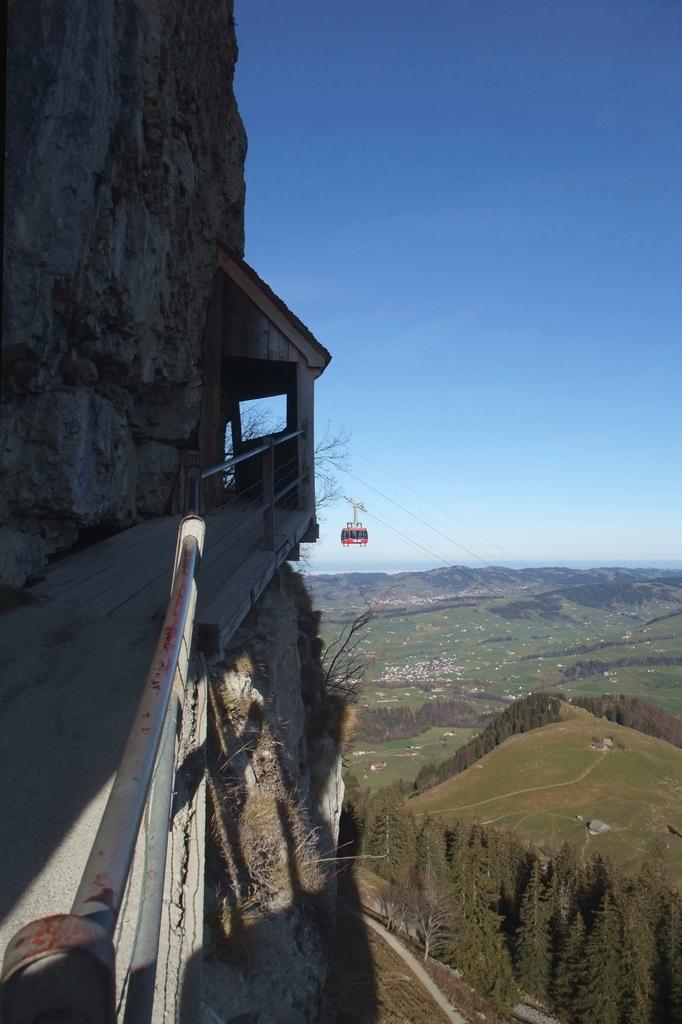What can be seen at the top of the image? The sky is visible in the image. What type of landform is present in the image? There is a mountain and a hill in the image. What color is the berry that is being picked by the eye in the image? There is no berry or eye present in the image; it only features a sky, a mountain, and a hill. 